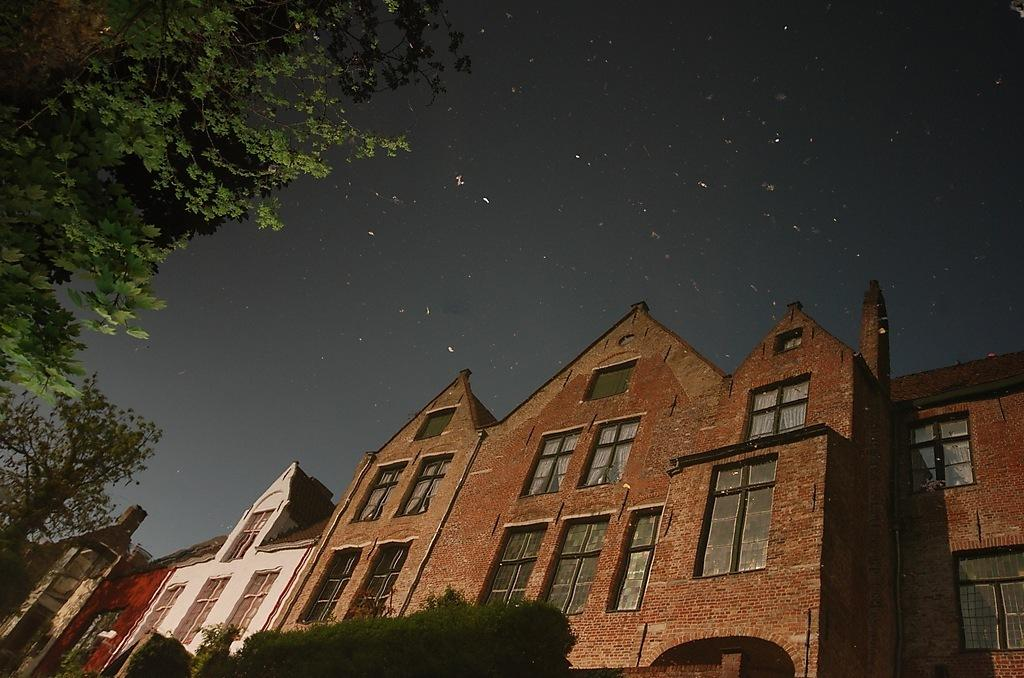What structures are visible in the image? There are buildings in the image. What type of vegetation is present in front of the buildings? There are trees in front of the buildings. What part of the natural environment can be seen behind the buildings? The sky is visible behind the buildings. What type of cemetery can be seen in the image? There is no cemetery present in the image; it features buildings, trees, and the sky. What sense is being stimulated by the colors in the image? The image does not focus on colors, so it is not possible to determine which sense is being stimulated. 